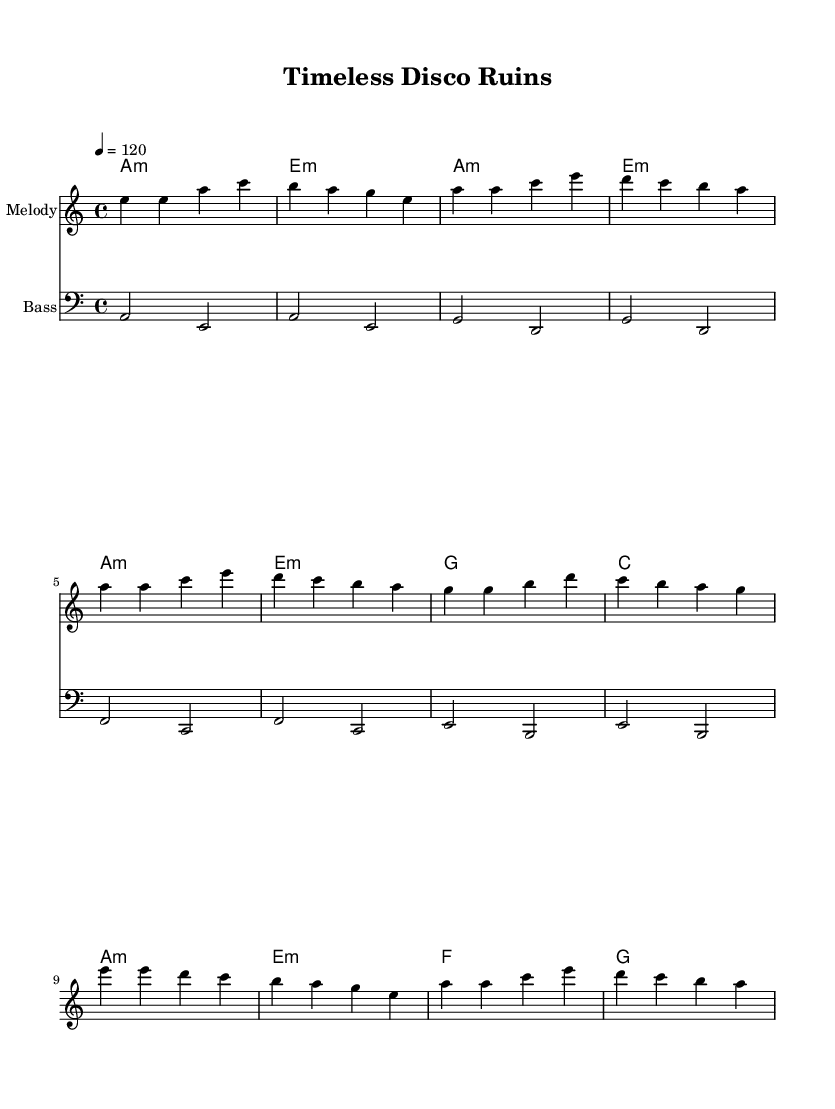What is the key signature of this music? The key signature is indicated by the sharp or flat symbols, but since there are no sharps or flats shown in the music, we determine that it is A minor, which has no accidental notes in its signature.
Answer: A minor What is the time signature of this piece? The time signature is shown just after the key signature at the beginning of the music. It indicates that there are four beats in each measure, which is represented as 4/4.
Answer: 4/4 What is the tempo marking for this piece? The tempo is expressed as a numeric marking in beats per minute at the beginning of the score. Here, it is indicated as 4 equals 120, meaning there are 120 beats per minute.
Answer: 120 How many measures are in the chorus section? By counting the measures in the chorus section as outlined in the music, we find that there are four distinct measures in that part of the piece.
Answer: 4 What is the first note of the melody? The first note of the melody is indicated at the very first position of the score. In this case, it is an E note, played an octave higher in the melody line.
Answer: E What chord follows A minor in the verse? The verse section begins with A minor and follows with E minor, where the chord progression is listed in the harmonies section of the score.
Answer: E minor What is the bass clef range used in this piece? The music shows a bass staff, which typically covers the notes from low E to high D in standard bass notation. Observing the notes in the bass part allows us to conclude this overall range.
Answer: E to D 